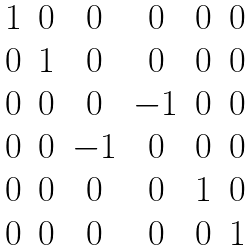Convert formula to latex. <formula><loc_0><loc_0><loc_500><loc_500>\begin{matrix} 1 & 0 & 0 & 0 & 0 & 0 \\ 0 & 1 & 0 & 0 & 0 & 0 \\ 0 & 0 & 0 & - 1 & 0 & 0 \\ 0 & 0 & - 1 & 0 & 0 & 0 \\ 0 & 0 & 0 & 0 & 1 & 0 \\ 0 & 0 & 0 & 0 & 0 & 1 \end{matrix}</formula> 